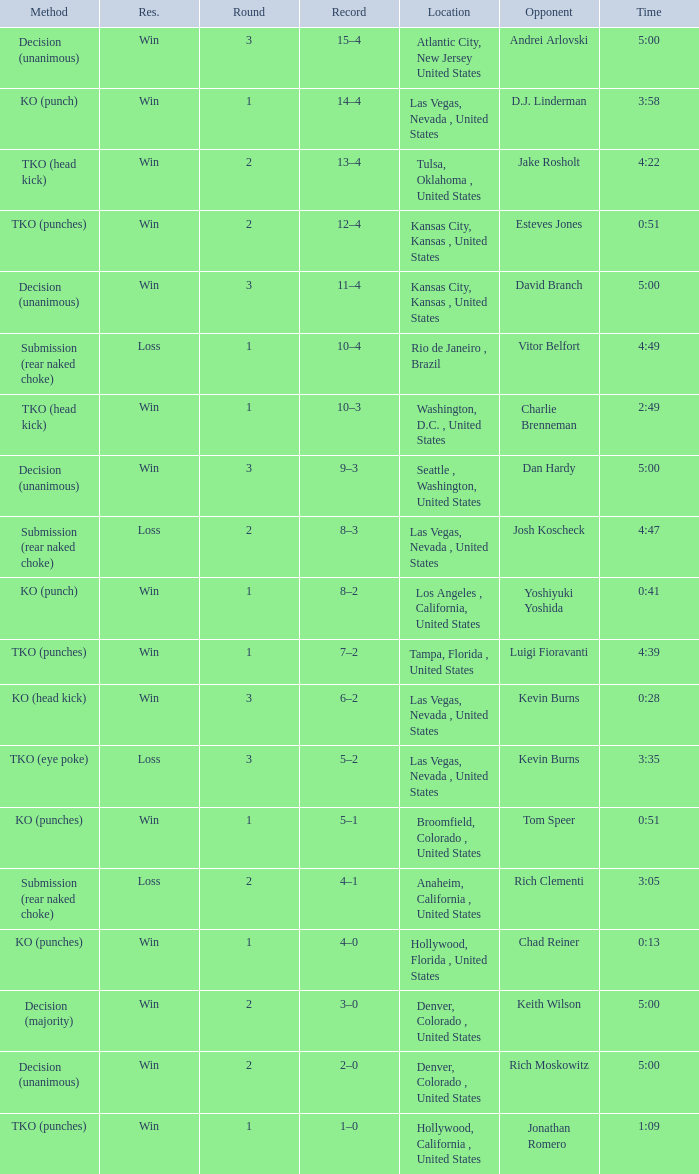What is the highest round number with a time of 4:39? 1.0. 